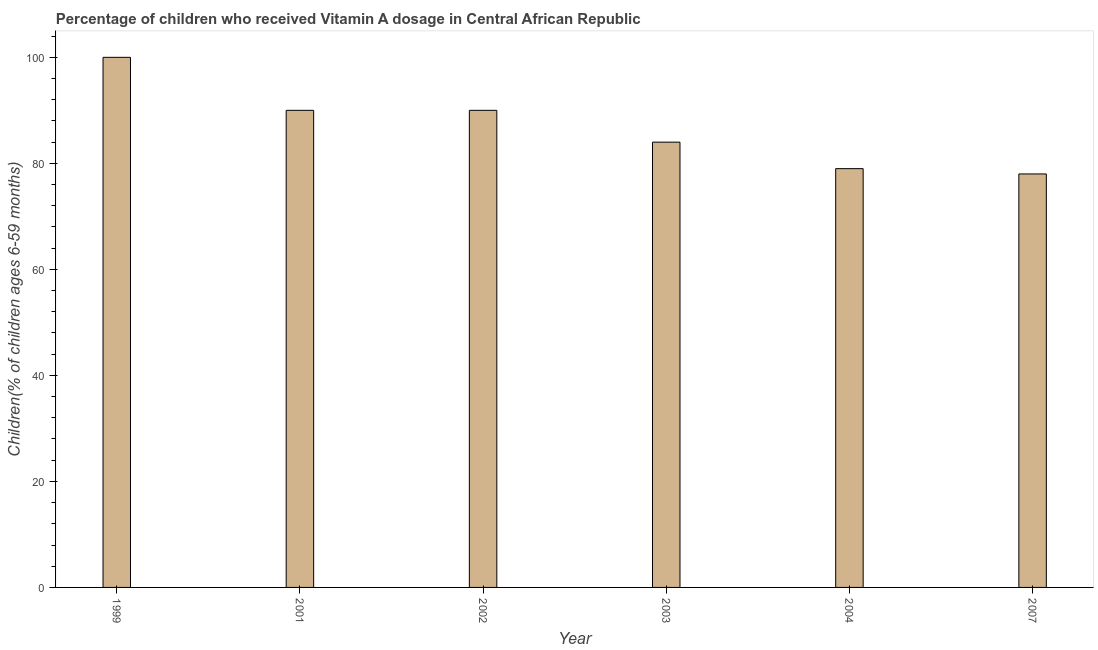Does the graph contain grids?
Provide a succinct answer. No. What is the title of the graph?
Your answer should be very brief. Percentage of children who received Vitamin A dosage in Central African Republic. What is the label or title of the X-axis?
Your answer should be compact. Year. What is the label or title of the Y-axis?
Provide a succinct answer. Children(% of children ages 6-59 months). What is the vitamin a supplementation coverage rate in 2004?
Your response must be concise. 79. Across all years, what is the minimum vitamin a supplementation coverage rate?
Provide a short and direct response. 78. In which year was the vitamin a supplementation coverage rate maximum?
Make the answer very short. 1999. In which year was the vitamin a supplementation coverage rate minimum?
Offer a terse response. 2007. What is the sum of the vitamin a supplementation coverage rate?
Provide a short and direct response. 521. In how many years, is the vitamin a supplementation coverage rate greater than 40 %?
Make the answer very short. 6. Do a majority of the years between 2003 and 2004 (inclusive) have vitamin a supplementation coverage rate greater than 44 %?
Offer a very short reply. Yes. What is the ratio of the vitamin a supplementation coverage rate in 1999 to that in 2007?
Make the answer very short. 1.28. Is the vitamin a supplementation coverage rate in 2002 less than that in 2004?
Provide a succinct answer. No. Is the difference between the vitamin a supplementation coverage rate in 1999 and 2007 greater than the difference between any two years?
Give a very brief answer. Yes. What is the difference between the highest and the lowest vitamin a supplementation coverage rate?
Your response must be concise. 22. Are all the bars in the graph horizontal?
Provide a short and direct response. No. How many years are there in the graph?
Keep it short and to the point. 6. What is the Children(% of children ages 6-59 months) in 2001?
Make the answer very short. 90. What is the Children(% of children ages 6-59 months) of 2002?
Your answer should be very brief. 90. What is the Children(% of children ages 6-59 months) of 2003?
Make the answer very short. 84. What is the Children(% of children ages 6-59 months) in 2004?
Provide a succinct answer. 79. What is the difference between the Children(% of children ages 6-59 months) in 1999 and 2001?
Give a very brief answer. 10. What is the difference between the Children(% of children ages 6-59 months) in 1999 and 2002?
Provide a succinct answer. 10. What is the difference between the Children(% of children ages 6-59 months) in 2001 and 2002?
Your answer should be very brief. 0. What is the difference between the Children(% of children ages 6-59 months) in 2002 and 2004?
Your answer should be compact. 11. What is the difference between the Children(% of children ages 6-59 months) in 2002 and 2007?
Your answer should be very brief. 12. What is the difference between the Children(% of children ages 6-59 months) in 2003 and 2004?
Give a very brief answer. 5. What is the difference between the Children(% of children ages 6-59 months) in 2004 and 2007?
Your response must be concise. 1. What is the ratio of the Children(% of children ages 6-59 months) in 1999 to that in 2001?
Your response must be concise. 1.11. What is the ratio of the Children(% of children ages 6-59 months) in 1999 to that in 2002?
Offer a terse response. 1.11. What is the ratio of the Children(% of children ages 6-59 months) in 1999 to that in 2003?
Make the answer very short. 1.19. What is the ratio of the Children(% of children ages 6-59 months) in 1999 to that in 2004?
Keep it short and to the point. 1.27. What is the ratio of the Children(% of children ages 6-59 months) in 1999 to that in 2007?
Offer a terse response. 1.28. What is the ratio of the Children(% of children ages 6-59 months) in 2001 to that in 2003?
Offer a terse response. 1.07. What is the ratio of the Children(% of children ages 6-59 months) in 2001 to that in 2004?
Offer a very short reply. 1.14. What is the ratio of the Children(% of children ages 6-59 months) in 2001 to that in 2007?
Your answer should be compact. 1.15. What is the ratio of the Children(% of children ages 6-59 months) in 2002 to that in 2003?
Your answer should be very brief. 1.07. What is the ratio of the Children(% of children ages 6-59 months) in 2002 to that in 2004?
Provide a succinct answer. 1.14. What is the ratio of the Children(% of children ages 6-59 months) in 2002 to that in 2007?
Your response must be concise. 1.15. What is the ratio of the Children(% of children ages 6-59 months) in 2003 to that in 2004?
Ensure brevity in your answer.  1.06. What is the ratio of the Children(% of children ages 6-59 months) in 2003 to that in 2007?
Keep it short and to the point. 1.08. 